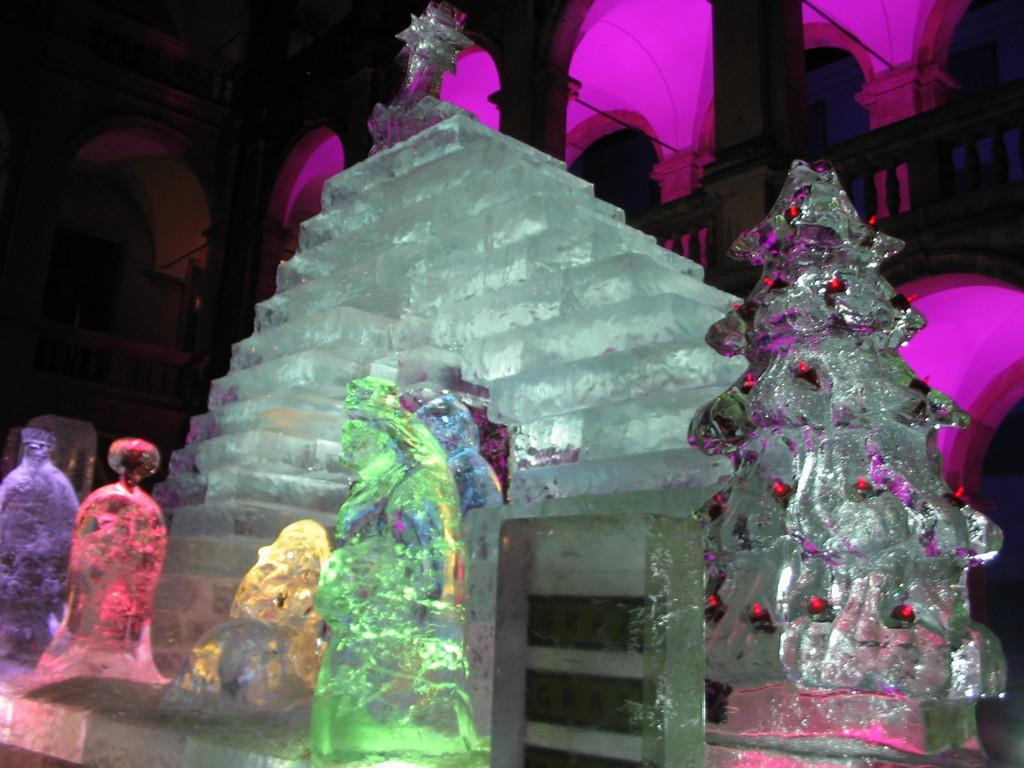Describe this image in one or two sentences. In the foreground of this picture, we can see few sculpture made with white stone and few lights attached to it. In the background, there is a building and a pink light. 